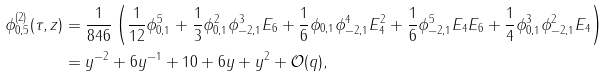Convert formula to latex. <formula><loc_0><loc_0><loc_500><loc_500>\phi _ { 0 , 5 } ^ { ( 2 ) } ( \tau , z ) & = \frac { 1 } { 8 4 6 } \left ( \frac { 1 } { 1 2 } \phi _ { 0 , 1 } ^ { 5 } + \frac { 1 } { 3 } \phi _ { 0 , 1 } ^ { 2 } \phi _ { - 2 , 1 } ^ { 3 } E _ { 6 } + \frac { 1 } { 6 } \phi _ { 0 , 1 } \phi _ { - 2 , 1 } ^ { 4 } E _ { 4 } ^ { 2 } + \frac { 1 } { 6 } \phi _ { - 2 , 1 } ^ { 5 } E _ { 4 } E _ { 6 } + \frac { 1 } { 4 } \phi _ { 0 , 1 } ^ { 3 } \phi _ { - 2 , 1 } ^ { 2 } E _ { 4 } \right ) \\ & = y ^ { - 2 } + 6 y ^ { - 1 } + 1 0 + 6 y + y ^ { 2 } + \mathcal { O } ( q ) ,</formula> 